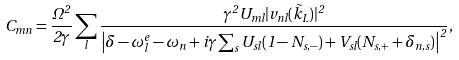<formula> <loc_0><loc_0><loc_500><loc_500>C _ { m n } = \frac { \Omega ^ { 2 } } { 2 \gamma } \sum _ { l } \frac { \gamma ^ { 2 } U _ { m l } | v _ { n l } ( \vec { k } _ { L } ) | ^ { 2 } } { \left | \delta - \omega ^ { e } _ { l } - \omega _ { n } + i \gamma \sum _ { s } U _ { s l } ( 1 - N _ { s , - } ) + V _ { s l } ( N _ { s , + } + \delta _ { n , s } ) \right | ^ { 2 } } ,</formula> 